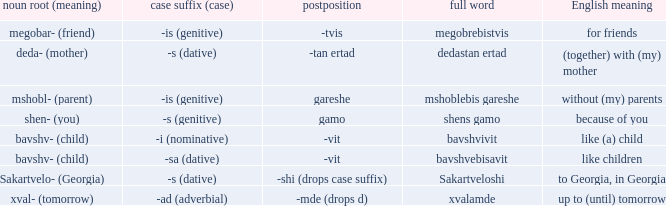When the noun root is "mshobl- (parent)", what does postposition refer to? Gareshe. 